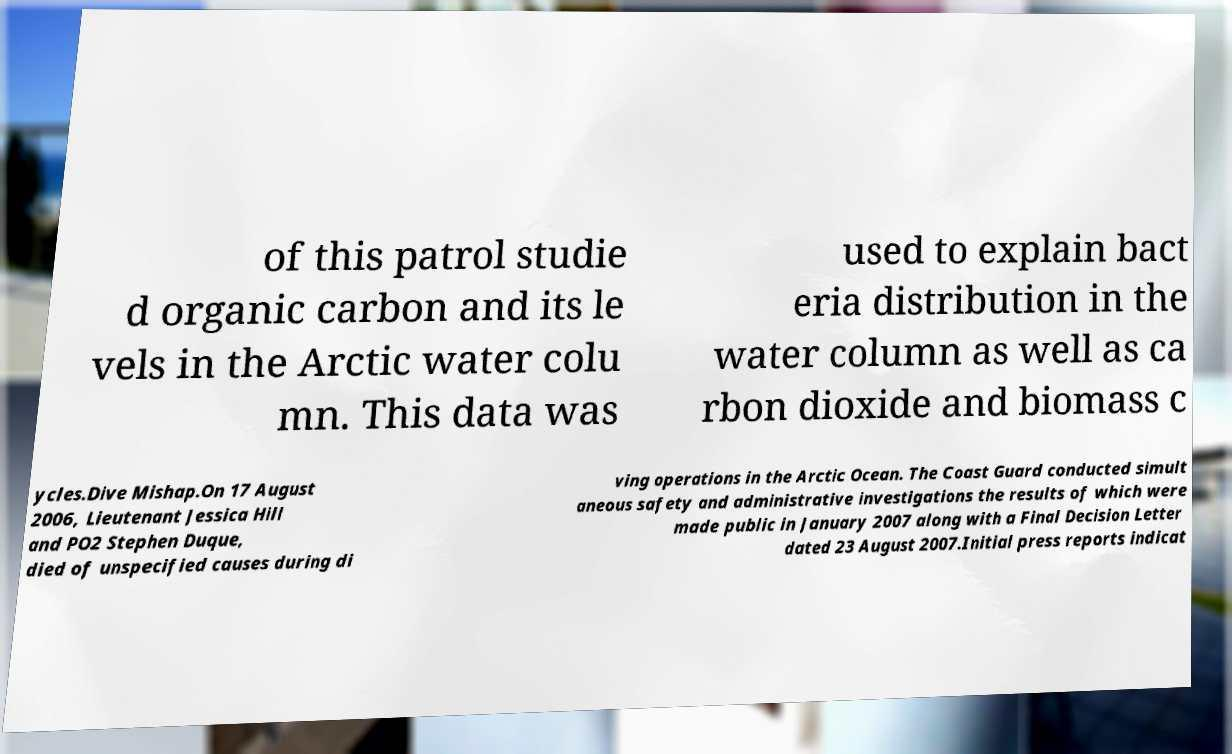Could you extract and type out the text from this image? of this patrol studie d organic carbon and its le vels in the Arctic water colu mn. This data was used to explain bact eria distribution in the water column as well as ca rbon dioxide and biomass c ycles.Dive Mishap.On 17 August 2006, Lieutenant Jessica Hill and PO2 Stephen Duque, died of unspecified causes during di ving operations in the Arctic Ocean. The Coast Guard conducted simult aneous safety and administrative investigations the results of which were made public in January 2007 along with a Final Decision Letter dated 23 August 2007.Initial press reports indicat 